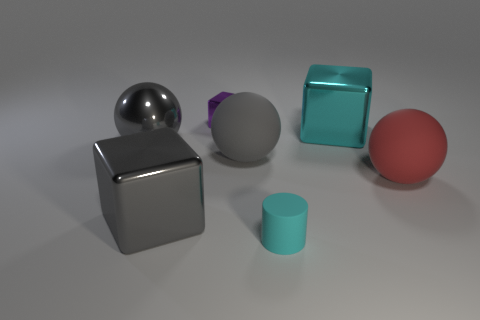Add 3 tiny blue balls. How many objects exist? 10 Subtract all balls. How many objects are left? 4 Subtract all small metal objects. Subtract all gray balls. How many objects are left? 4 Add 3 purple blocks. How many purple blocks are left? 4 Add 3 red matte balls. How many red matte balls exist? 4 Subtract 0 green cubes. How many objects are left? 7 